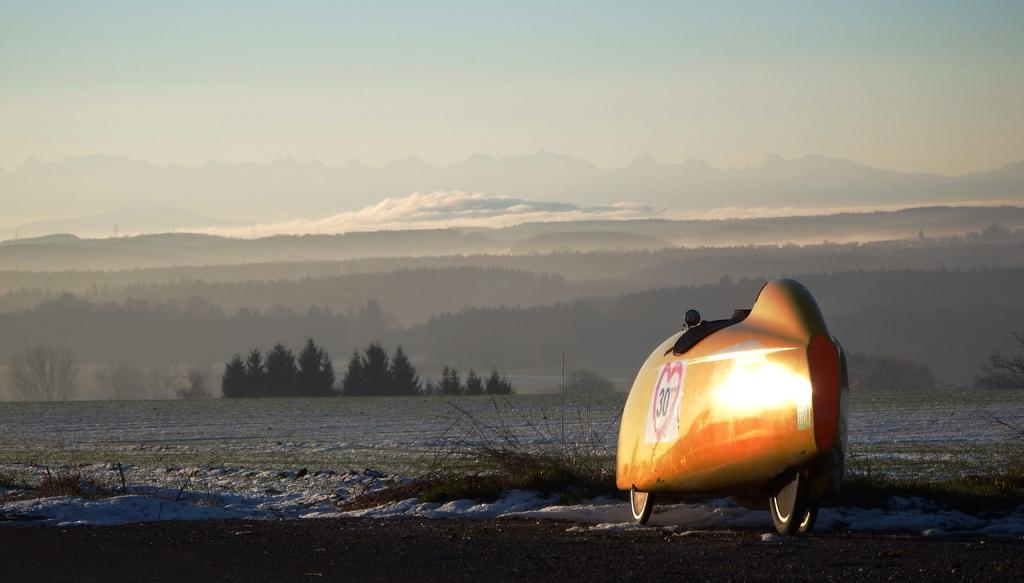What is the main subject of the image? There is a vehicle in the image. What can be seen in the background of the image? There are trees, hills, and the sky visible in the background of the image. What type of terrain is present in the image? There is grass in the image. How much debt does the horse in the image have? There is no horse present in the image, so it is impossible to determine any debt associated with it. 